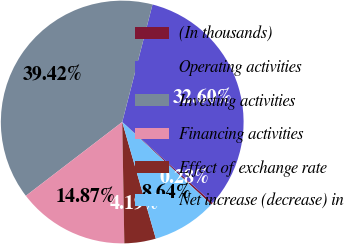Convert chart. <chart><loc_0><loc_0><loc_500><loc_500><pie_chart><fcel>(In thousands)<fcel>Operating activities<fcel>Investing activities<fcel>Financing activities<fcel>Effect of exchange rate<fcel>Net increase (decrease) in<nl><fcel>0.28%<fcel>32.6%<fcel>39.42%<fcel>14.87%<fcel>4.19%<fcel>8.64%<nl></chart> 